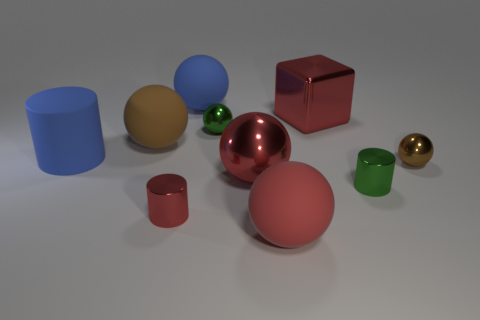Subtract all small brown balls. How many balls are left? 5 Subtract all brown spheres. How many spheres are left? 4 Subtract 2 spheres. How many spheres are left? 4 Subtract all blue spheres. Subtract all green cylinders. How many spheres are left? 5 Subtract all spheres. How many objects are left? 4 Add 5 red metallic balls. How many red metallic balls are left? 6 Add 7 gray cylinders. How many gray cylinders exist? 7 Subtract 1 green balls. How many objects are left? 9 Subtract all blue cylinders. Subtract all cubes. How many objects are left? 8 